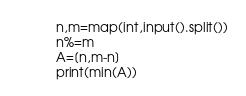Convert code to text. <code><loc_0><loc_0><loc_500><loc_500><_Python_>n,m=map(int,input().split())
n%=m
A=[n,m-n]
print(min(A))</code> 